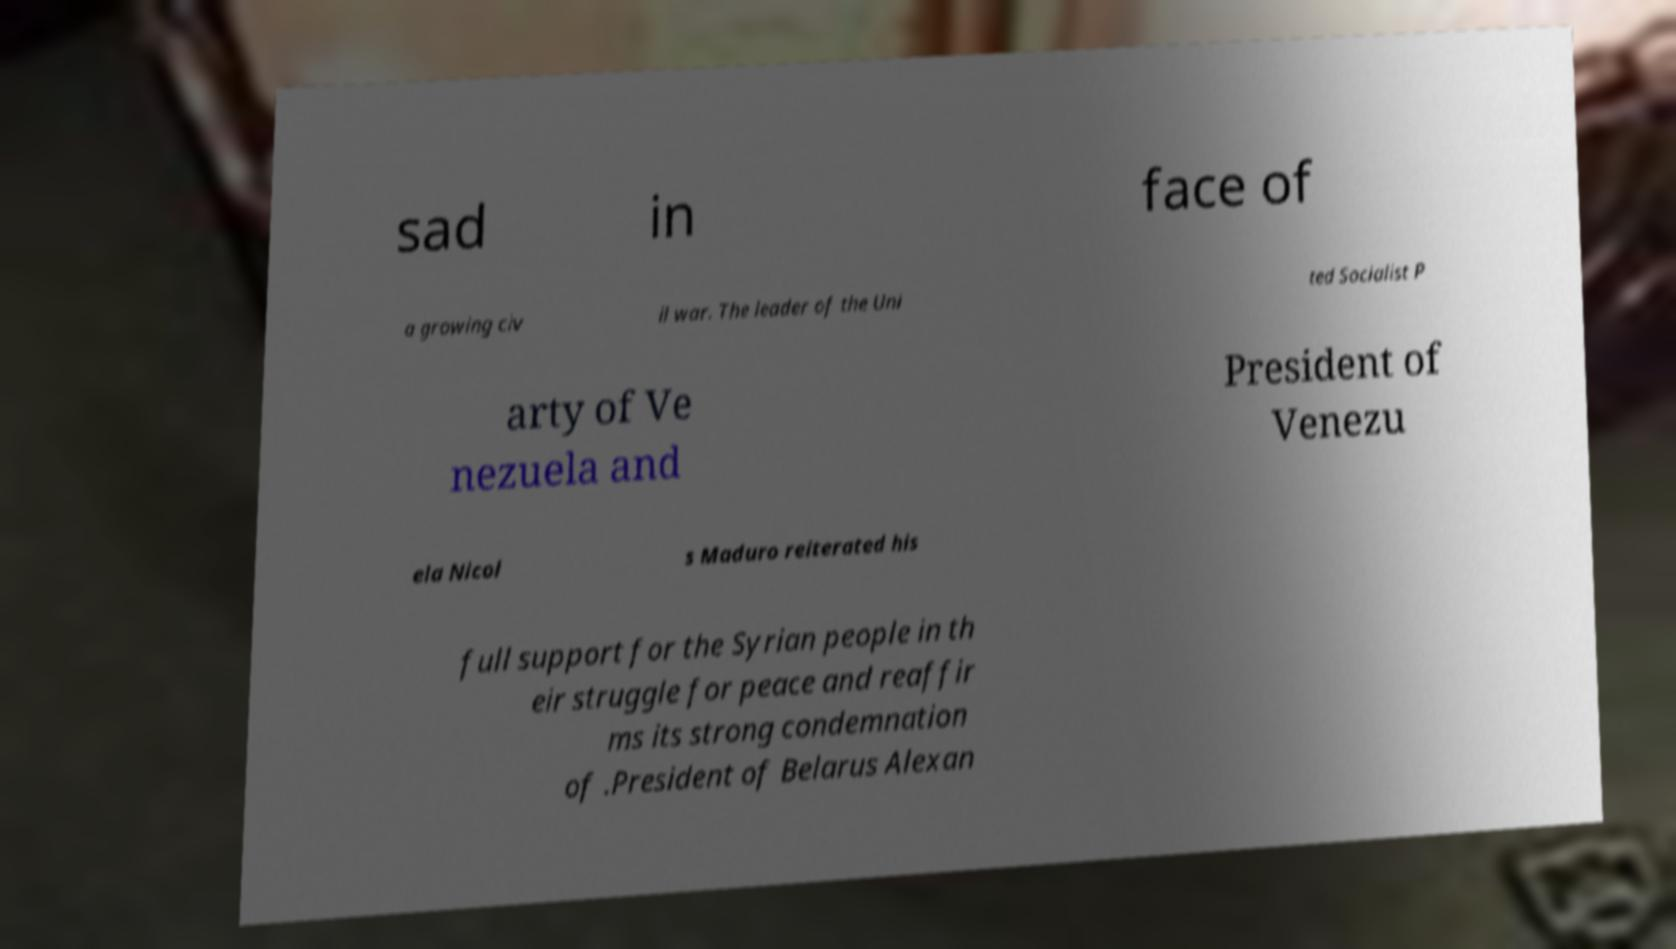Could you assist in decoding the text presented in this image and type it out clearly? sad in face of a growing civ il war. The leader of the Uni ted Socialist P arty of Ve nezuela and President of Venezu ela Nicol s Maduro reiterated his full support for the Syrian people in th eir struggle for peace and reaffir ms its strong condemnation of .President of Belarus Alexan 